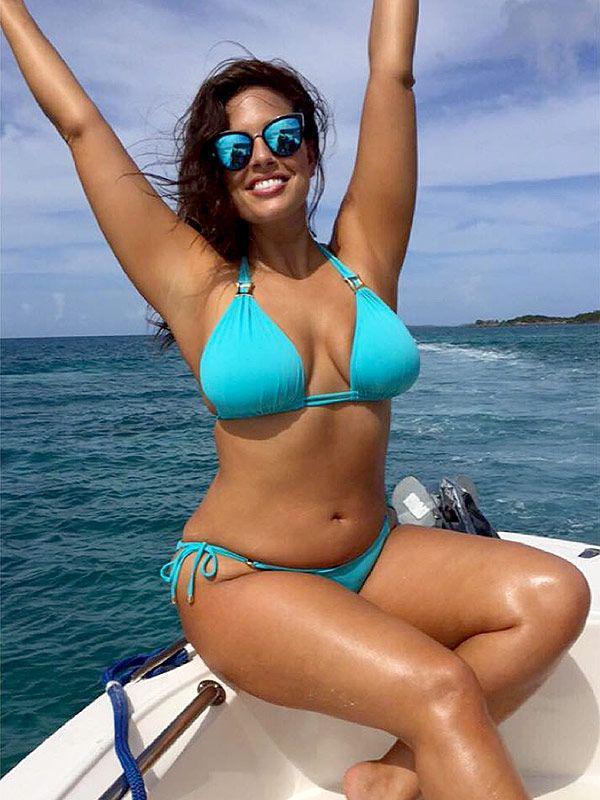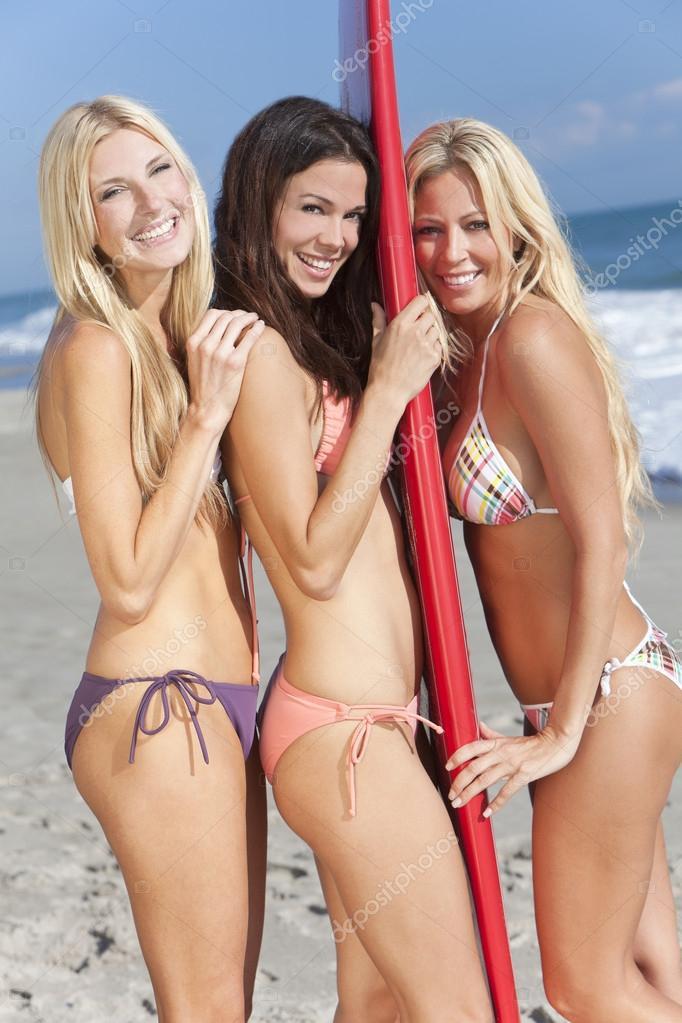The first image is the image on the left, the second image is the image on the right. Given the left and right images, does the statement "Right image shows three bikini-wearing women standing close together." hold true? Answer yes or no. Yes. The first image is the image on the left, the second image is the image on the right. Considering the images on both sides, is "There is at least one pregnant woman." valid? Answer yes or no. No. 